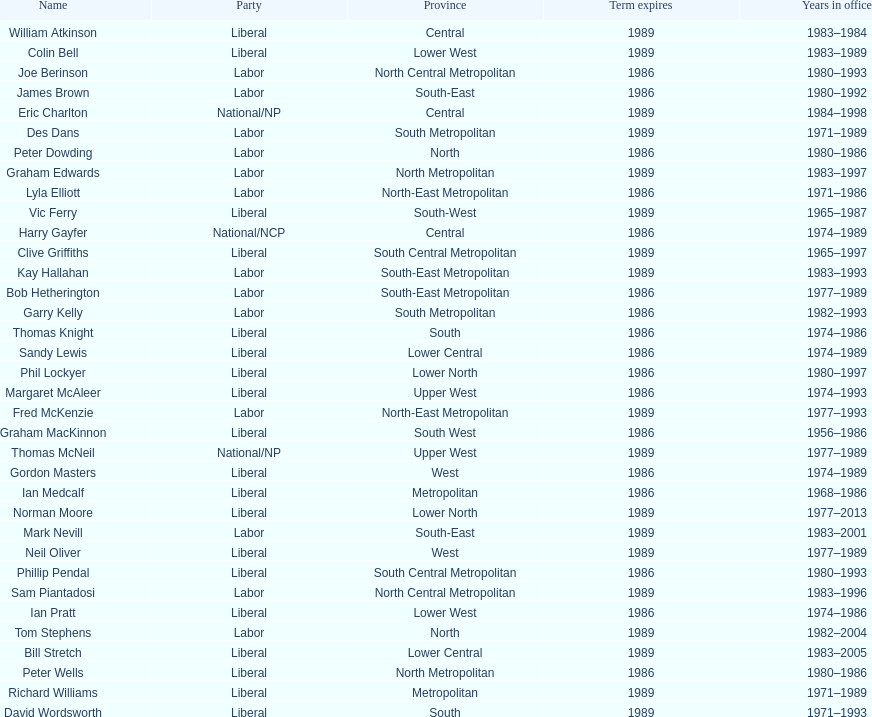Who has had the shortest term in office William Atkinson. 